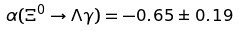<formula> <loc_0><loc_0><loc_500><loc_500>\alpha ( \Xi ^ { 0 } \to \Lambda \gamma ) = - 0 . 6 5 \pm 0 . 1 9</formula> 